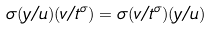Convert formula to latex. <formula><loc_0><loc_0><loc_500><loc_500>\sigma ( y / u ) ( v / t ^ { \sigma } ) = \sigma ( v / t ^ { \sigma } ) ( y / u )</formula> 